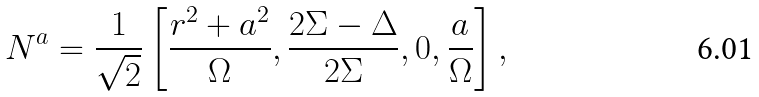<formula> <loc_0><loc_0><loc_500><loc_500>N ^ { a } = \frac { 1 } { \sqrt { 2 } } \left [ \frac { r ^ { 2 } + a ^ { 2 } } { \Omega } , \frac { 2 \Sigma - \Delta } { 2 \Sigma } , 0 , \frac { a } { \Omega } \right ] ,</formula> 